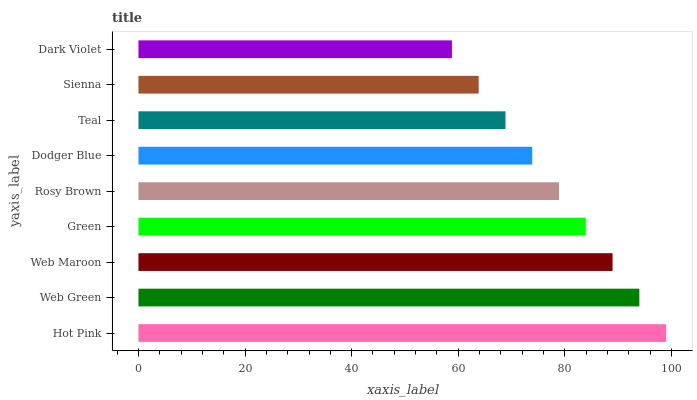Is Dark Violet the minimum?
Answer yes or no. Yes. Is Hot Pink the maximum?
Answer yes or no. Yes. Is Web Green the minimum?
Answer yes or no. No. Is Web Green the maximum?
Answer yes or no. No. Is Hot Pink greater than Web Green?
Answer yes or no. Yes. Is Web Green less than Hot Pink?
Answer yes or no. Yes. Is Web Green greater than Hot Pink?
Answer yes or no. No. Is Hot Pink less than Web Green?
Answer yes or no. No. Is Rosy Brown the high median?
Answer yes or no. Yes. Is Rosy Brown the low median?
Answer yes or no. Yes. Is Web Green the high median?
Answer yes or no. No. Is Green the low median?
Answer yes or no. No. 